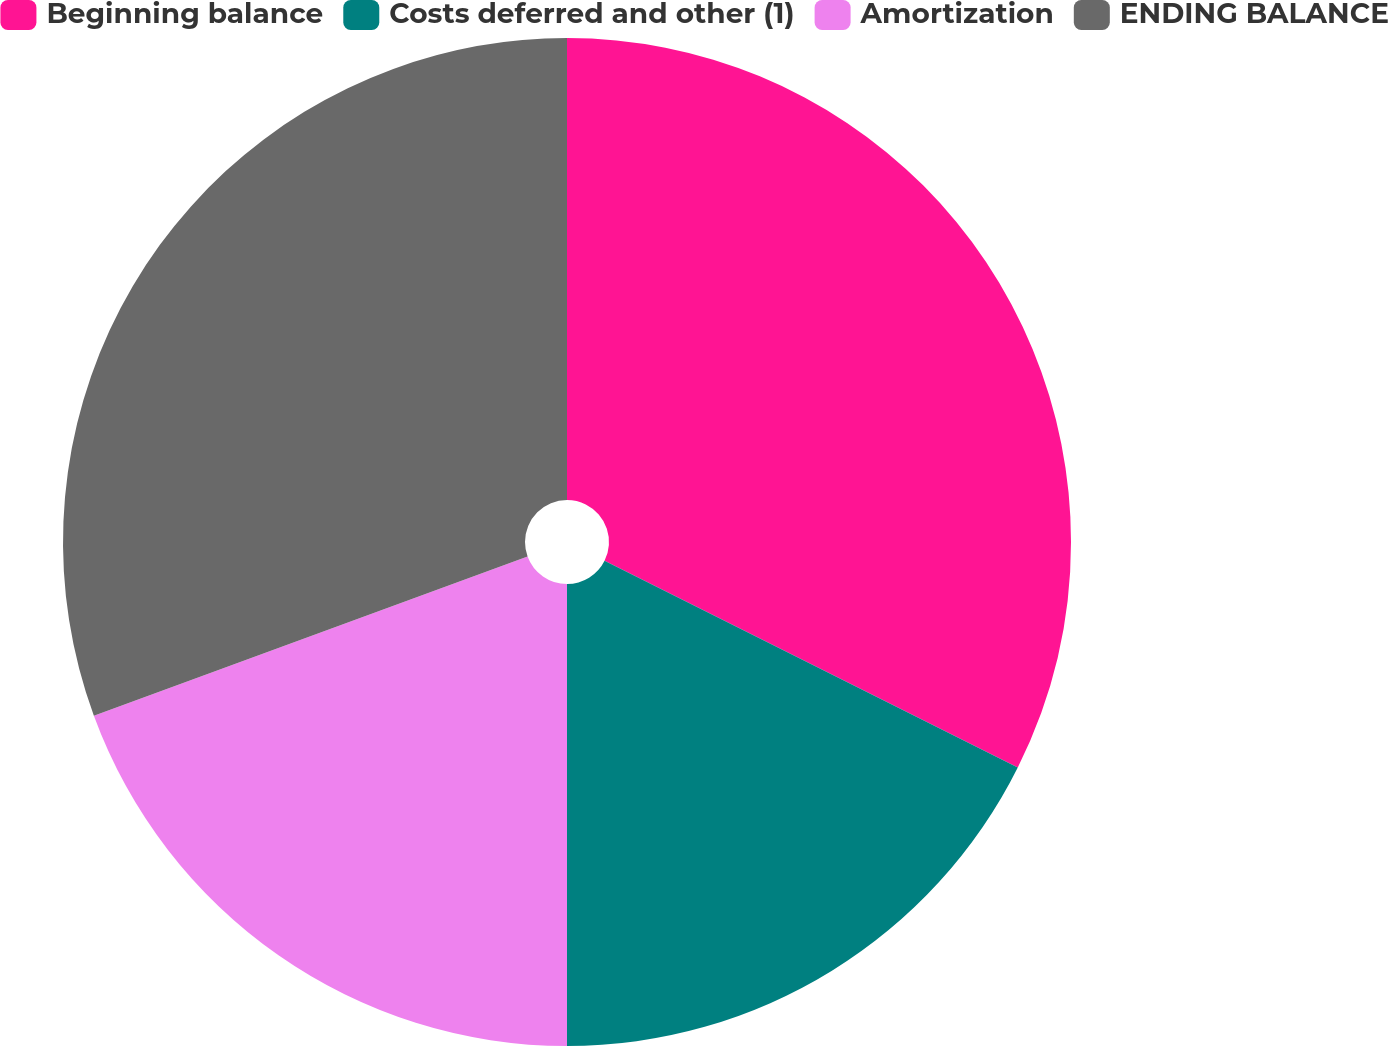Convert chart. <chart><loc_0><loc_0><loc_500><loc_500><pie_chart><fcel>Beginning balance<fcel>Costs deferred and other (1)<fcel>Amortization<fcel>ENDING BALANCE<nl><fcel>32.38%<fcel>17.62%<fcel>19.4%<fcel>30.6%<nl></chart> 